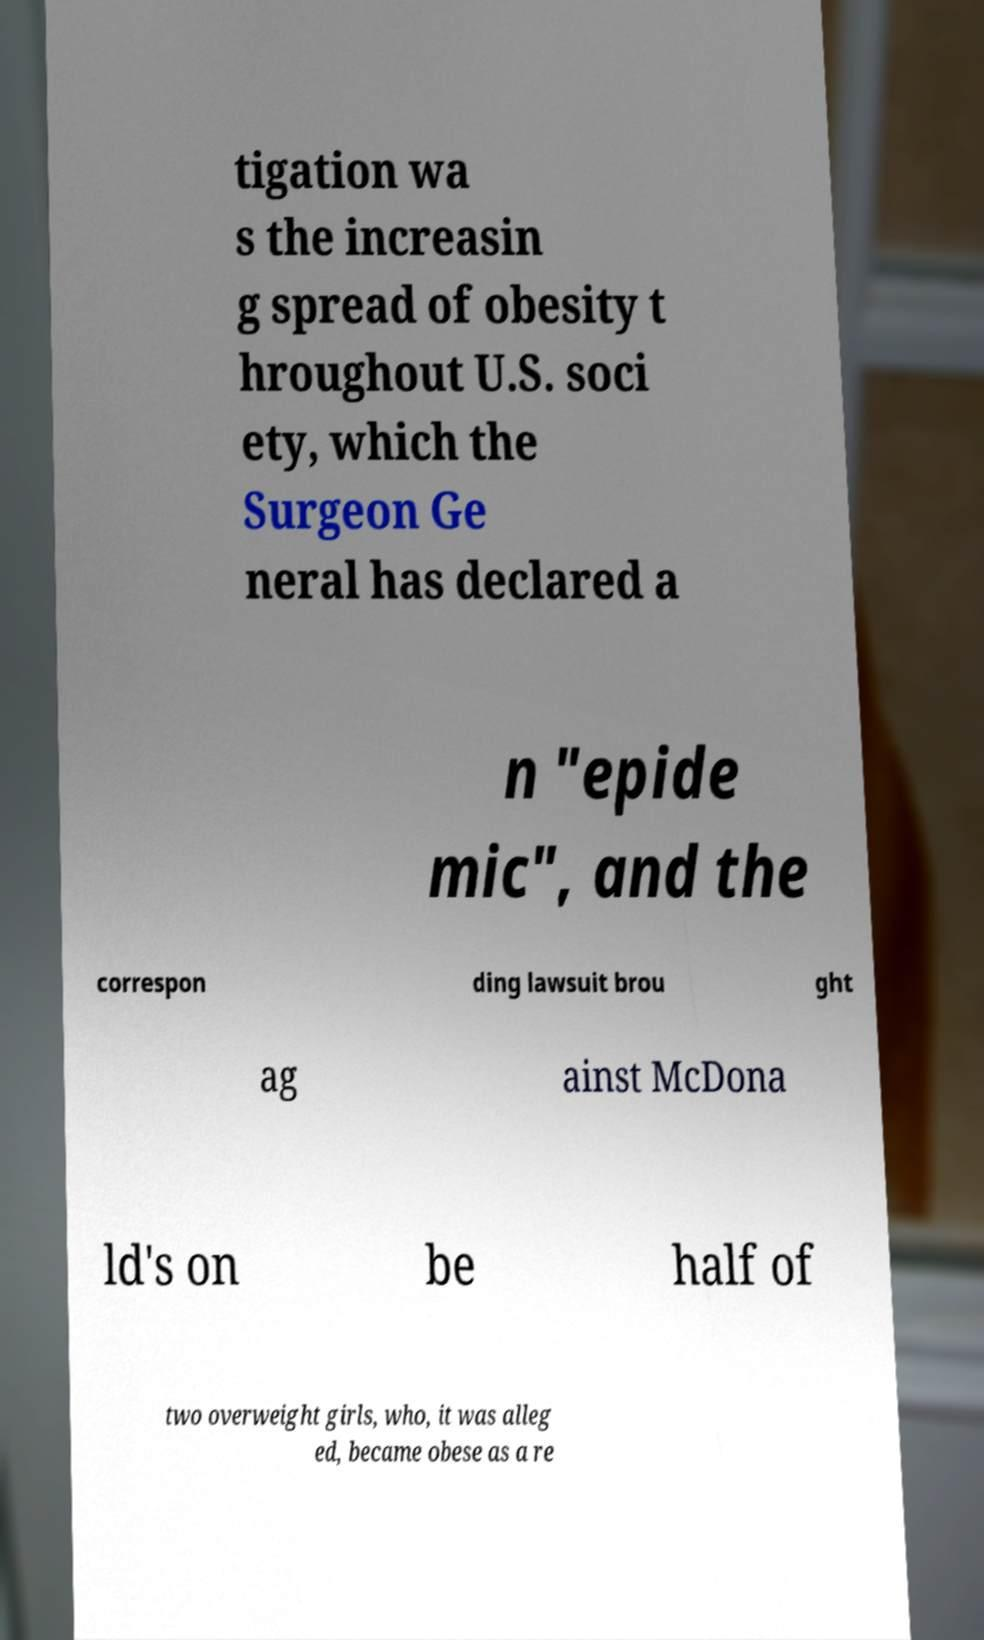There's text embedded in this image that I need extracted. Can you transcribe it verbatim? tigation wa s the increasin g spread of obesity t hroughout U.S. soci ety, which the Surgeon Ge neral has declared a n "epide mic", and the correspon ding lawsuit brou ght ag ainst McDona ld's on be half of two overweight girls, who, it was alleg ed, became obese as a re 